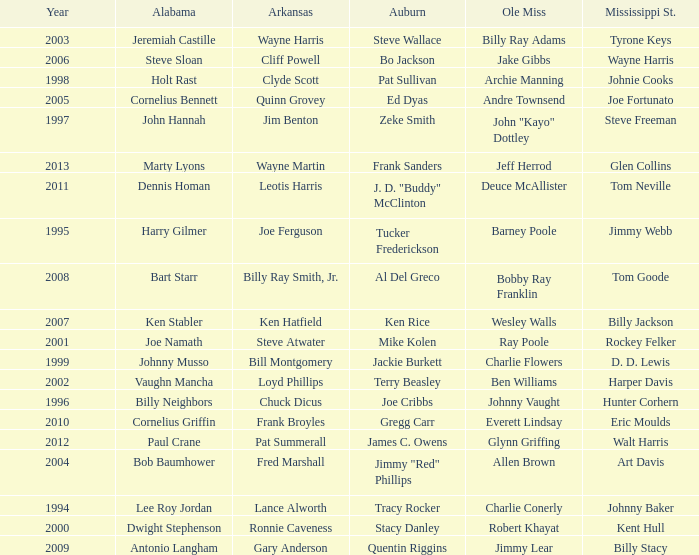Who was the Mississippi State player associated with Cornelius Bennett? Joe Fortunato. 